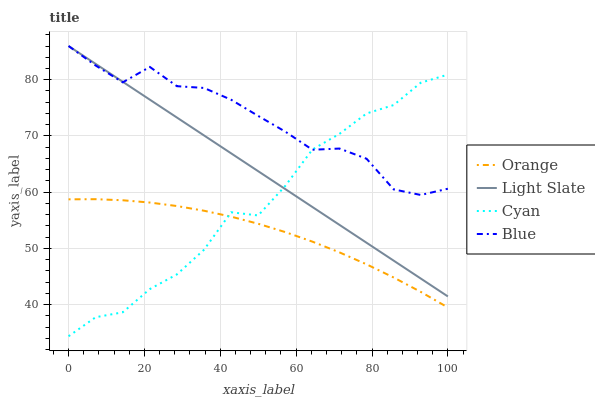Does Light Slate have the minimum area under the curve?
Answer yes or no. No. Does Light Slate have the maximum area under the curve?
Answer yes or no. No. Is Blue the smoothest?
Answer yes or no. No. Is Blue the roughest?
Answer yes or no. No. Does Light Slate have the lowest value?
Answer yes or no. No. Does Cyan have the highest value?
Answer yes or no. No. Is Orange less than Blue?
Answer yes or no. Yes. Is Light Slate greater than Orange?
Answer yes or no. Yes. Does Orange intersect Blue?
Answer yes or no. No. 